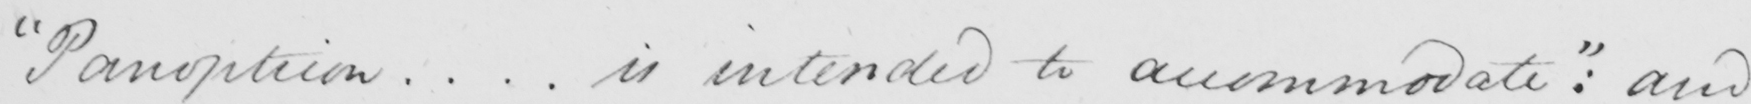What does this handwritten line say? " Panopticon  .  .  .  . is intended to accommodate "  :  and 